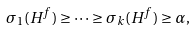<formula> <loc_0><loc_0><loc_500><loc_500>\sigma _ { 1 } ( H ^ { f } ) \geq \dots \geq \sigma _ { k } ( H ^ { f } ) \geq \alpha ,</formula> 